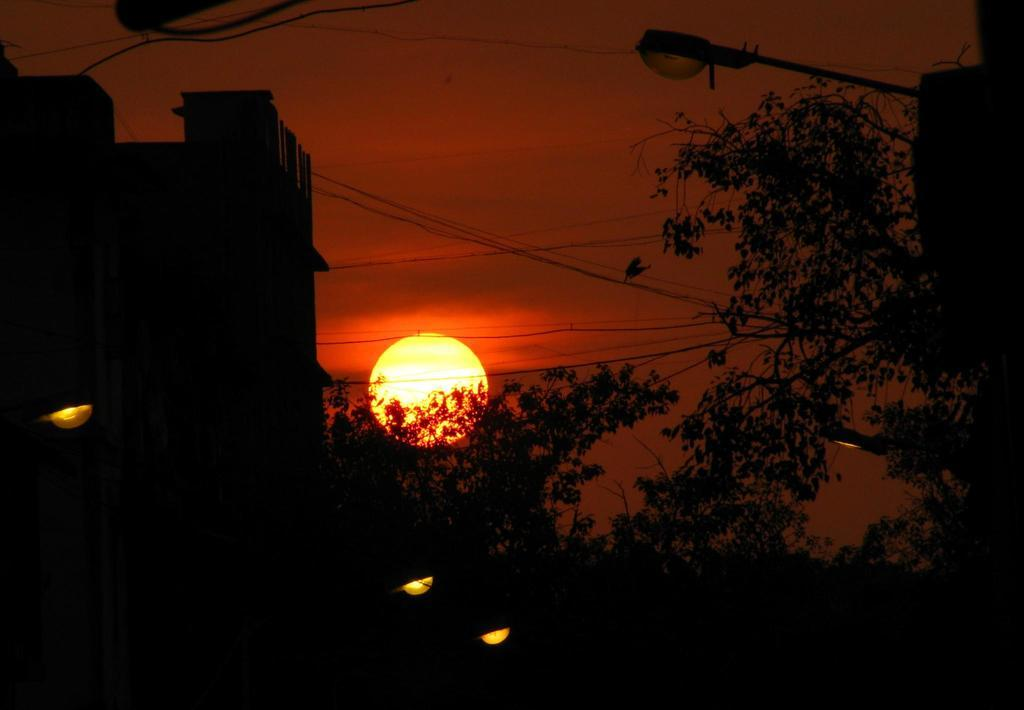What type of vegetation is present in the image? There are trees in the image. Where is the light pole located in the image? The light pole is on the right side of the image. What structure can be seen on the left side of the image? There is a building on the left side of the image. What else can be seen in the image besides the trees and building? There are wires visible in the image. What is the condition of the sky in the image? The sun is visible in the sky, indicating that it is daytime. What type of soda is being served at the visitor's table in the image? There is no visitor or table present in the image, and therefore no soda can be observed. What type of yam is growing on the light pole in the image? There is no yam present in the image; the light pole is not a plant or vegetation. 